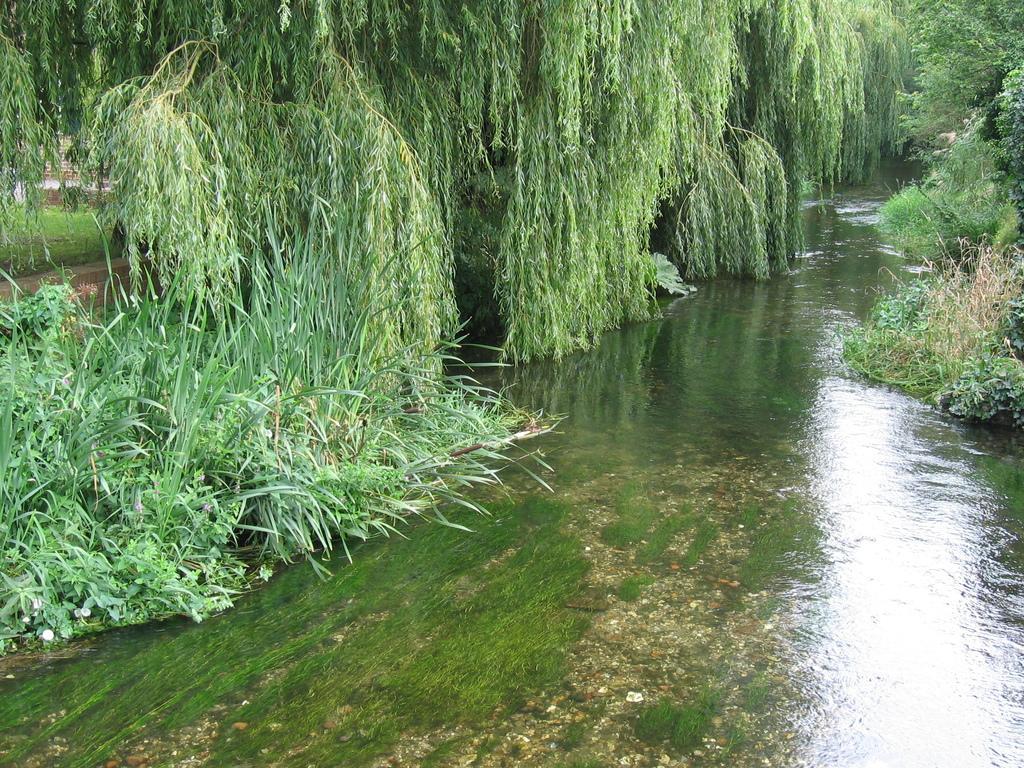In one or two sentences, can you explain what this image depicts? In this picture we can see trees, water, stones and in the background we can see the grass. 